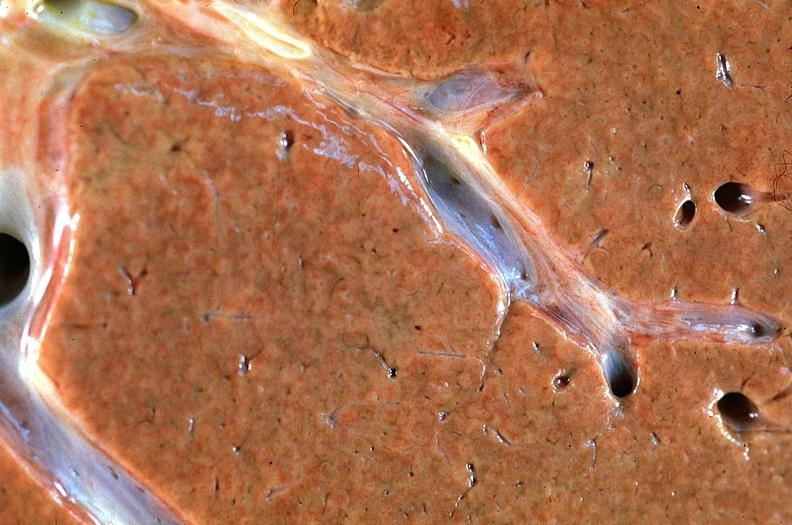what is present?
Answer the question using a single word or phrase. Hepatobiliary 